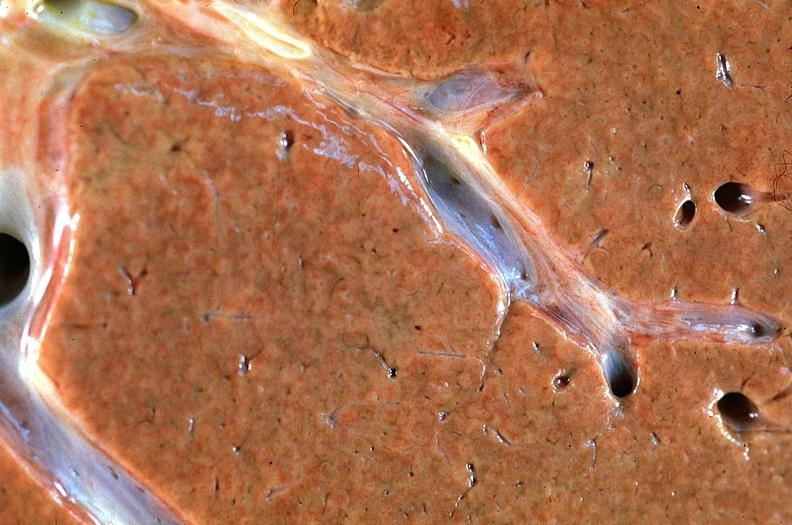what is present?
Answer the question using a single word or phrase. Hepatobiliary 